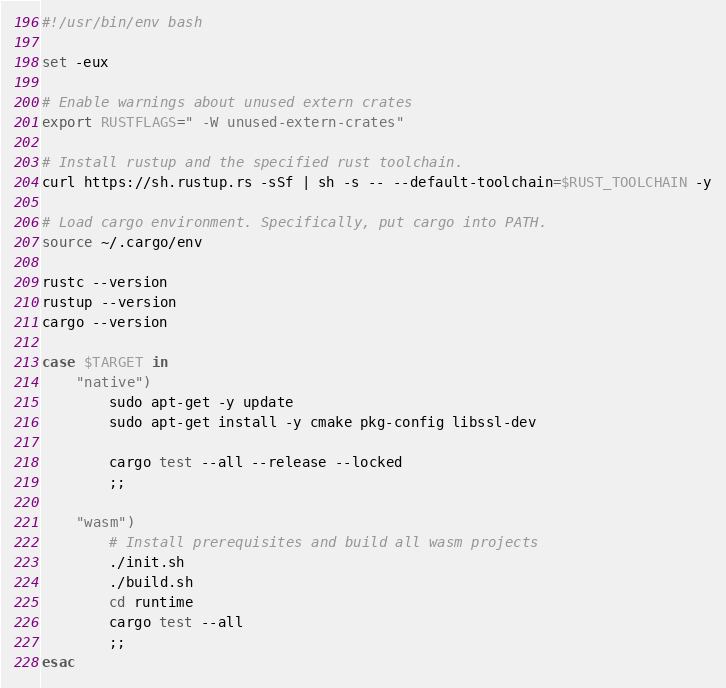<code> <loc_0><loc_0><loc_500><loc_500><_Bash_>#!/usr/bin/env bash

set -eux

# Enable warnings about unused extern crates
export RUSTFLAGS=" -W unused-extern-crates"

# Install rustup and the specified rust toolchain.
curl https://sh.rustup.rs -sSf | sh -s -- --default-toolchain=$RUST_TOOLCHAIN -y

# Load cargo environment. Specifically, put cargo into PATH.
source ~/.cargo/env

rustc --version
rustup --version
cargo --version

case $TARGET in
	"native")
		sudo apt-get -y update
		sudo apt-get install -y cmake pkg-config libssl-dev

		cargo test --all --release --locked
		;;

	"wasm")
		# Install prerequisites and build all wasm projects
		./init.sh
		./build.sh
		cd runtime
		cargo test --all
		;;
esac
</code> 